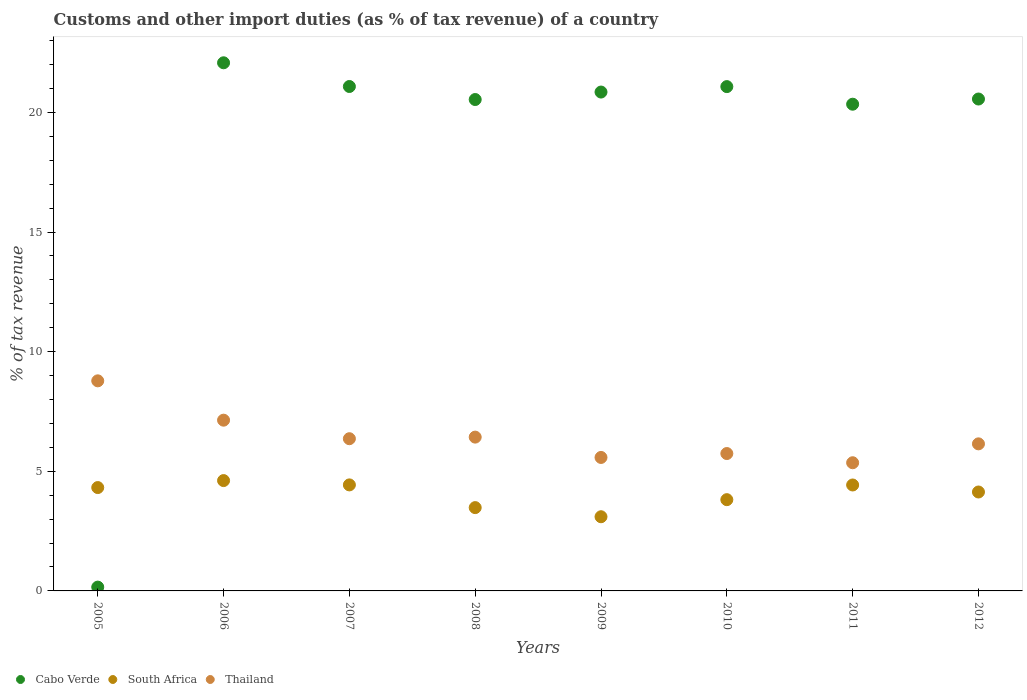How many different coloured dotlines are there?
Offer a terse response. 3. What is the percentage of tax revenue from customs in Cabo Verde in 2007?
Provide a succinct answer. 21.08. Across all years, what is the maximum percentage of tax revenue from customs in Cabo Verde?
Provide a succinct answer. 22.07. Across all years, what is the minimum percentage of tax revenue from customs in South Africa?
Keep it short and to the point. 3.1. In which year was the percentage of tax revenue from customs in Cabo Verde maximum?
Provide a short and direct response. 2006. In which year was the percentage of tax revenue from customs in South Africa minimum?
Provide a short and direct response. 2009. What is the total percentage of tax revenue from customs in Thailand in the graph?
Your answer should be very brief. 51.53. What is the difference between the percentage of tax revenue from customs in Thailand in 2008 and that in 2011?
Provide a short and direct response. 1.07. What is the difference between the percentage of tax revenue from customs in South Africa in 2006 and the percentage of tax revenue from customs in Thailand in 2012?
Make the answer very short. -1.54. What is the average percentage of tax revenue from customs in South Africa per year?
Your response must be concise. 4.04. In the year 2005, what is the difference between the percentage of tax revenue from customs in South Africa and percentage of tax revenue from customs in Cabo Verde?
Your answer should be compact. 4.16. In how many years, is the percentage of tax revenue from customs in Cabo Verde greater than 10 %?
Make the answer very short. 7. What is the ratio of the percentage of tax revenue from customs in South Africa in 2008 to that in 2010?
Your response must be concise. 0.91. Is the percentage of tax revenue from customs in South Africa in 2007 less than that in 2009?
Your answer should be very brief. No. What is the difference between the highest and the second highest percentage of tax revenue from customs in Thailand?
Your answer should be very brief. 1.64. What is the difference between the highest and the lowest percentage of tax revenue from customs in South Africa?
Ensure brevity in your answer.  1.51. Is it the case that in every year, the sum of the percentage of tax revenue from customs in South Africa and percentage of tax revenue from customs in Cabo Verde  is greater than the percentage of tax revenue from customs in Thailand?
Provide a succinct answer. No. Does the percentage of tax revenue from customs in South Africa monotonically increase over the years?
Your response must be concise. No. How many dotlines are there?
Your answer should be compact. 3. How many years are there in the graph?
Your answer should be very brief. 8. Are the values on the major ticks of Y-axis written in scientific E-notation?
Offer a terse response. No. Does the graph contain any zero values?
Ensure brevity in your answer.  No. How many legend labels are there?
Your response must be concise. 3. How are the legend labels stacked?
Your answer should be very brief. Horizontal. What is the title of the graph?
Offer a very short reply. Customs and other import duties (as % of tax revenue) of a country. What is the label or title of the X-axis?
Keep it short and to the point. Years. What is the label or title of the Y-axis?
Keep it short and to the point. % of tax revenue. What is the % of tax revenue of Cabo Verde in 2005?
Ensure brevity in your answer.  0.16. What is the % of tax revenue of South Africa in 2005?
Your response must be concise. 4.32. What is the % of tax revenue in Thailand in 2005?
Offer a terse response. 8.78. What is the % of tax revenue in Cabo Verde in 2006?
Make the answer very short. 22.07. What is the % of tax revenue of South Africa in 2006?
Provide a succinct answer. 4.61. What is the % of tax revenue in Thailand in 2006?
Provide a succinct answer. 7.14. What is the % of tax revenue of Cabo Verde in 2007?
Provide a short and direct response. 21.08. What is the % of tax revenue of South Africa in 2007?
Ensure brevity in your answer.  4.43. What is the % of tax revenue of Thailand in 2007?
Make the answer very short. 6.36. What is the % of tax revenue in Cabo Verde in 2008?
Offer a terse response. 20.54. What is the % of tax revenue of South Africa in 2008?
Offer a terse response. 3.48. What is the % of tax revenue of Thailand in 2008?
Ensure brevity in your answer.  6.43. What is the % of tax revenue in Cabo Verde in 2009?
Provide a succinct answer. 20.85. What is the % of tax revenue in South Africa in 2009?
Your answer should be compact. 3.1. What is the % of tax revenue of Thailand in 2009?
Offer a terse response. 5.58. What is the % of tax revenue in Cabo Verde in 2010?
Your answer should be compact. 21.08. What is the % of tax revenue of South Africa in 2010?
Your answer should be compact. 3.81. What is the % of tax revenue in Thailand in 2010?
Provide a short and direct response. 5.74. What is the % of tax revenue in Cabo Verde in 2011?
Your response must be concise. 20.34. What is the % of tax revenue in South Africa in 2011?
Your answer should be very brief. 4.43. What is the % of tax revenue in Thailand in 2011?
Your response must be concise. 5.36. What is the % of tax revenue of Cabo Verde in 2012?
Offer a very short reply. 20.56. What is the % of tax revenue in South Africa in 2012?
Your response must be concise. 4.13. What is the % of tax revenue in Thailand in 2012?
Make the answer very short. 6.15. Across all years, what is the maximum % of tax revenue in Cabo Verde?
Make the answer very short. 22.07. Across all years, what is the maximum % of tax revenue of South Africa?
Ensure brevity in your answer.  4.61. Across all years, what is the maximum % of tax revenue of Thailand?
Offer a very short reply. 8.78. Across all years, what is the minimum % of tax revenue in Cabo Verde?
Your answer should be compact. 0.16. Across all years, what is the minimum % of tax revenue in South Africa?
Offer a terse response. 3.1. Across all years, what is the minimum % of tax revenue of Thailand?
Keep it short and to the point. 5.36. What is the total % of tax revenue in Cabo Verde in the graph?
Ensure brevity in your answer.  146.69. What is the total % of tax revenue in South Africa in the graph?
Keep it short and to the point. 32.32. What is the total % of tax revenue in Thailand in the graph?
Your response must be concise. 51.53. What is the difference between the % of tax revenue of Cabo Verde in 2005 and that in 2006?
Provide a short and direct response. -21.91. What is the difference between the % of tax revenue in South Africa in 2005 and that in 2006?
Offer a terse response. -0.29. What is the difference between the % of tax revenue of Thailand in 2005 and that in 2006?
Keep it short and to the point. 1.64. What is the difference between the % of tax revenue in Cabo Verde in 2005 and that in 2007?
Your answer should be very brief. -20.92. What is the difference between the % of tax revenue in South Africa in 2005 and that in 2007?
Your response must be concise. -0.11. What is the difference between the % of tax revenue in Thailand in 2005 and that in 2007?
Your answer should be compact. 2.42. What is the difference between the % of tax revenue of Cabo Verde in 2005 and that in 2008?
Offer a very short reply. -20.38. What is the difference between the % of tax revenue of South Africa in 2005 and that in 2008?
Ensure brevity in your answer.  0.84. What is the difference between the % of tax revenue of Thailand in 2005 and that in 2008?
Provide a succinct answer. 2.35. What is the difference between the % of tax revenue of Cabo Verde in 2005 and that in 2009?
Make the answer very short. -20.69. What is the difference between the % of tax revenue in South Africa in 2005 and that in 2009?
Keep it short and to the point. 1.22. What is the difference between the % of tax revenue of Thailand in 2005 and that in 2009?
Your answer should be very brief. 3.2. What is the difference between the % of tax revenue in Cabo Verde in 2005 and that in 2010?
Make the answer very short. -20.92. What is the difference between the % of tax revenue in South Africa in 2005 and that in 2010?
Provide a short and direct response. 0.51. What is the difference between the % of tax revenue of Thailand in 2005 and that in 2010?
Ensure brevity in your answer.  3.04. What is the difference between the % of tax revenue in Cabo Verde in 2005 and that in 2011?
Keep it short and to the point. -20.18. What is the difference between the % of tax revenue of South Africa in 2005 and that in 2011?
Provide a short and direct response. -0.11. What is the difference between the % of tax revenue in Thailand in 2005 and that in 2011?
Provide a short and direct response. 3.42. What is the difference between the % of tax revenue of Cabo Verde in 2005 and that in 2012?
Make the answer very short. -20.4. What is the difference between the % of tax revenue in South Africa in 2005 and that in 2012?
Offer a terse response. 0.19. What is the difference between the % of tax revenue of Thailand in 2005 and that in 2012?
Provide a succinct answer. 2.63. What is the difference between the % of tax revenue of Cabo Verde in 2006 and that in 2007?
Your answer should be compact. 0.99. What is the difference between the % of tax revenue in South Africa in 2006 and that in 2007?
Your response must be concise. 0.18. What is the difference between the % of tax revenue of Thailand in 2006 and that in 2007?
Give a very brief answer. 0.77. What is the difference between the % of tax revenue of Cabo Verde in 2006 and that in 2008?
Your answer should be compact. 1.54. What is the difference between the % of tax revenue of South Africa in 2006 and that in 2008?
Offer a very short reply. 1.13. What is the difference between the % of tax revenue of Thailand in 2006 and that in 2008?
Provide a succinct answer. 0.71. What is the difference between the % of tax revenue in Cabo Verde in 2006 and that in 2009?
Your answer should be very brief. 1.22. What is the difference between the % of tax revenue of South Africa in 2006 and that in 2009?
Offer a terse response. 1.51. What is the difference between the % of tax revenue in Thailand in 2006 and that in 2009?
Ensure brevity in your answer.  1.56. What is the difference between the % of tax revenue of South Africa in 2006 and that in 2010?
Make the answer very short. 0.8. What is the difference between the % of tax revenue in Thailand in 2006 and that in 2010?
Give a very brief answer. 1.39. What is the difference between the % of tax revenue in Cabo Verde in 2006 and that in 2011?
Offer a terse response. 1.73. What is the difference between the % of tax revenue of South Africa in 2006 and that in 2011?
Your response must be concise. 0.18. What is the difference between the % of tax revenue in Thailand in 2006 and that in 2011?
Ensure brevity in your answer.  1.78. What is the difference between the % of tax revenue of Cabo Verde in 2006 and that in 2012?
Offer a terse response. 1.51. What is the difference between the % of tax revenue of South Africa in 2006 and that in 2012?
Provide a short and direct response. 0.48. What is the difference between the % of tax revenue of Thailand in 2006 and that in 2012?
Your answer should be very brief. 0.99. What is the difference between the % of tax revenue in Cabo Verde in 2007 and that in 2008?
Your response must be concise. 0.54. What is the difference between the % of tax revenue in South Africa in 2007 and that in 2008?
Make the answer very short. 0.95. What is the difference between the % of tax revenue in Thailand in 2007 and that in 2008?
Provide a short and direct response. -0.07. What is the difference between the % of tax revenue in Cabo Verde in 2007 and that in 2009?
Make the answer very short. 0.23. What is the difference between the % of tax revenue of South Africa in 2007 and that in 2009?
Your answer should be compact. 1.33. What is the difference between the % of tax revenue of Thailand in 2007 and that in 2009?
Provide a succinct answer. 0.78. What is the difference between the % of tax revenue of Cabo Verde in 2007 and that in 2010?
Offer a terse response. 0. What is the difference between the % of tax revenue of South Africa in 2007 and that in 2010?
Keep it short and to the point. 0.62. What is the difference between the % of tax revenue of Thailand in 2007 and that in 2010?
Keep it short and to the point. 0.62. What is the difference between the % of tax revenue in Cabo Verde in 2007 and that in 2011?
Offer a very short reply. 0.74. What is the difference between the % of tax revenue in South Africa in 2007 and that in 2011?
Your answer should be very brief. 0. What is the difference between the % of tax revenue in Cabo Verde in 2007 and that in 2012?
Keep it short and to the point. 0.52. What is the difference between the % of tax revenue of South Africa in 2007 and that in 2012?
Your answer should be very brief. 0.3. What is the difference between the % of tax revenue in Thailand in 2007 and that in 2012?
Offer a very short reply. 0.21. What is the difference between the % of tax revenue of Cabo Verde in 2008 and that in 2009?
Provide a short and direct response. -0.31. What is the difference between the % of tax revenue in South Africa in 2008 and that in 2009?
Ensure brevity in your answer.  0.38. What is the difference between the % of tax revenue of Thailand in 2008 and that in 2009?
Provide a succinct answer. 0.85. What is the difference between the % of tax revenue in Cabo Verde in 2008 and that in 2010?
Provide a succinct answer. -0.54. What is the difference between the % of tax revenue of South Africa in 2008 and that in 2010?
Your response must be concise. -0.33. What is the difference between the % of tax revenue in Thailand in 2008 and that in 2010?
Provide a succinct answer. 0.69. What is the difference between the % of tax revenue in Cabo Verde in 2008 and that in 2011?
Your response must be concise. 0.2. What is the difference between the % of tax revenue of South Africa in 2008 and that in 2011?
Make the answer very short. -0.95. What is the difference between the % of tax revenue in Thailand in 2008 and that in 2011?
Make the answer very short. 1.07. What is the difference between the % of tax revenue of Cabo Verde in 2008 and that in 2012?
Offer a very short reply. -0.02. What is the difference between the % of tax revenue of South Africa in 2008 and that in 2012?
Your response must be concise. -0.65. What is the difference between the % of tax revenue in Thailand in 2008 and that in 2012?
Keep it short and to the point. 0.28. What is the difference between the % of tax revenue in Cabo Verde in 2009 and that in 2010?
Offer a terse response. -0.23. What is the difference between the % of tax revenue in South Africa in 2009 and that in 2010?
Ensure brevity in your answer.  -0.71. What is the difference between the % of tax revenue in Thailand in 2009 and that in 2010?
Ensure brevity in your answer.  -0.16. What is the difference between the % of tax revenue of Cabo Verde in 2009 and that in 2011?
Keep it short and to the point. 0.51. What is the difference between the % of tax revenue of South Africa in 2009 and that in 2011?
Your response must be concise. -1.33. What is the difference between the % of tax revenue in Thailand in 2009 and that in 2011?
Your response must be concise. 0.22. What is the difference between the % of tax revenue in Cabo Verde in 2009 and that in 2012?
Your answer should be compact. 0.29. What is the difference between the % of tax revenue in South Africa in 2009 and that in 2012?
Provide a short and direct response. -1.03. What is the difference between the % of tax revenue of Thailand in 2009 and that in 2012?
Ensure brevity in your answer.  -0.57. What is the difference between the % of tax revenue of Cabo Verde in 2010 and that in 2011?
Make the answer very short. 0.74. What is the difference between the % of tax revenue of South Africa in 2010 and that in 2011?
Keep it short and to the point. -0.61. What is the difference between the % of tax revenue of Thailand in 2010 and that in 2011?
Your response must be concise. 0.38. What is the difference between the % of tax revenue in Cabo Verde in 2010 and that in 2012?
Offer a terse response. 0.52. What is the difference between the % of tax revenue of South Africa in 2010 and that in 2012?
Your answer should be compact. -0.32. What is the difference between the % of tax revenue of Thailand in 2010 and that in 2012?
Ensure brevity in your answer.  -0.4. What is the difference between the % of tax revenue in Cabo Verde in 2011 and that in 2012?
Your response must be concise. -0.22. What is the difference between the % of tax revenue of South Africa in 2011 and that in 2012?
Offer a terse response. 0.29. What is the difference between the % of tax revenue of Thailand in 2011 and that in 2012?
Provide a short and direct response. -0.79. What is the difference between the % of tax revenue of Cabo Verde in 2005 and the % of tax revenue of South Africa in 2006?
Make the answer very short. -4.45. What is the difference between the % of tax revenue in Cabo Verde in 2005 and the % of tax revenue in Thailand in 2006?
Your answer should be compact. -6.98. What is the difference between the % of tax revenue of South Africa in 2005 and the % of tax revenue of Thailand in 2006?
Keep it short and to the point. -2.82. What is the difference between the % of tax revenue in Cabo Verde in 2005 and the % of tax revenue in South Africa in 2007?
Provide a succinct answer. -4.27. What is the difference between the % of tax revenue in Cabo Verde in 2005 and the % of tax revenue in Thailand in 2007?
Your response must be concise. -6.2. What is the difference between the % of tax revenue of South Africa in 2005 and the % of tax revenue of Thailand in 2007?
Provide a succinct answer. -2.04. What is the difference between the % of tax revenue in Cabo Verde in 2005 and the % of tax revenue in South Africa in 2008?
Offer a terse response. -3.32. What is the difference between the % of tax revenue in Cabo Verde in 2005 and the % of tax revenue in Thailand in 2008?
Provide a succinct answer. -6.27. What is the difference between the % of tax revenue in South Africa in 2005 and the % of tax revenue in Thailand in 2008?
Provide a short and direct response. -2.11. What is the difference between the % of tax revenue of Cabo Verde in 2005 and the % of tax revenue of South Africa in 2009?
Make the answer very short. -2.94. What is the difference between the % of tax revenue of Cabo Verde in 2005 and the % of tax revenue of Thailand in 2009?
Ensure brevity in your answer.  -5.42. What is the difference between the % of tax revenue in South Africa in 2005 and the % of tax revenue in Thailand in 2009?
Make the answer very short. -1.26. What is the difference between the % of tax revenue in Cabo Verde in 2005 and the % of tax revenue in South Africa in 2010?
Make the answer very short. -3.65. What is the difference between the % of tax revenue in Cabo Verde in 2005 and the % of tax revenue in Thailand in 2010?
Make the answer very short. -5.58. What is the difference between the % of tax revenue in South Africa in 2005 and the % of tax revenue in Thailand in 2010?
Your answer should be compact. -1.42. What is the difference between the % of tax revenue in Cabo Verde in 2005 and the % of tax revenue in South Africa in 2011?
Provide a short and direct response. -4.27. What is the difference between the % of tax revenue of Cabo Verde in 2005 and the % of tax revenue of Thailand in 2011?
Provide a short and direct response. -5.2. What is the difference between the % of tax revenue in South Africa in 2005 and the % of tax revenue in Thailand in 2011?
Your response must be concise. -1.04. What is the difference between the % of tax revenue of Cabo Verde in 2005 and the % of tax revenue of South Africa in 2012?
Provide a short and direct response. -3.98. What is the difference between the % of tax revenue of Cabo Verde in 2005 and the % of tax revenue of Thailand in 2012?
Provide a succinct answer. -5.99. What is the difference between the % of tax revenue in South Africa in 2005 and the % of tax revenue in Thailand in 2012?
Provide a short and direct response. -1.83. What is the difference between the % of tax revenue in Cabo Verde in 2006 and the % of tax revenue in South Africa in 2007?
Offer a very short reply. 17.64. What is the difference between the % of tax revenue of Cabo Verde in 2006 and the % of tax revenue of Thailand in 2007?
Offer a very short reply. 15.71. What is the difference between the % of tax revenue in South Africa in 2006 and the % of tax revenue in Thailand in 2007?
Make the answer very short. -1.75. What is the difference between the % of tax revenue of Cabo Verde in 2006 and the % of tax revenue of South Africa in 2008?
Your answer should be very brief. 18.59. What is the difference between the % of tax revenue of Cabo Verde in 2006 and the % of tax revenue of Thailand in 2008?
Offer a very short reply. 15.65. What is the difference between the % of tax revenue in South Africa in 2006 and the % of tax revenue in Thailand in 2008?
Your response must be concise. -1.82. What is the difference between the % of tax revenue of Cabo Verde in 2006 and the % of tax revenue of South Africa in 2009?
Provide a succinct answer. 18.97. What is the difference between the % of tax revenue in Cabo Verde in 2006 and the % of tax revenue in Thailand in 2009?
Your answer should be compact. 16.5. What is the difference between the % of tax revenue of South Africa in 2006 and the % of tax revenue of Thailand in 2009?
Provide a succinct answer. -0.97. What is the difference between the % of tax revenue of Cabo Verde in 2006 and the % of tax revenue of South Africa in 2010?
Make the answer very short. 18.26. What is the difference between the % of tax revenue of Cabo Verde in 2006 and the % of tax revenue of Thailand in 2010?
Ensure brevity in your answer.  16.33. What is the difference between the % of tax revenue of South Africa in 2006 and the % of tax revenue of Thailand in 2010?
Provide a short and direct response. -1.13. What is the difference between the % of tax revenue of Cabo Verde in 2006 and the % of tax revenue of South Africa in 2011?
Your answer should be compact. 17.65. What is the difference between the % of tax revenue of Cabo Verde in 2006 and the % of tax revenue of Thailand in 2011?
Give a very brief answer. 16.72. What is the difference between the % of tax revenue of South Africa in 2006 and the % of tax revenue of Thailand in 2011?
Ensure brevity in your answer.  -0.75. What is the difference between the % of tax revenue in Cabo Verde in 2006 and the % of tax revenue in South Africa in 2012?
Provide a short and direct response. 17.94. What is the difference between the % of tax revenue of Cabo Verde in 2006 and the % of tax revenue of Thailand in 2012?
Make the answer very short. 15.93. What is the difference between the % of tax revenue of South Africa in 2006 and the % of tax revenue of Thailand in 2012?
Ensure brevity in your answer.  -1.54. What is the difference between the % of tax revenue of Cabo Verde in 2007 and the % of tax revenue of South Africa in 2008?
Your response must be concise. 17.6. What is the difference between the % of tax revenue in Cabo Verde in 2007 and the % of tax revenue in Thailand in 2008?
Make the answer very short. 14.65. What is the difference between the % of tax revenue of South Africa in 2007 and the % of tax revenue of Thailand in 2008?
Give a very brief answer. -2. What is the difference between the % of tax revenue in Cabo Verde in 2007 and the % of tax revenue in South Africa in 2009?
Make the answer very short. 17.98. What is the difference between the % of tax revenue in Cabo Verde in 2007 and the % of tax revenue in Thailand in 2009?
Give a very brief answer. 15.5. What is the difference between the % of tax revenue of South Africa in 2007 and the % of tax revenue of Thailand in 2009?
Offer a terse response. -1.15. What is the difference between the % of tax revenue in Cabo Verde in 2007 and the % of tax revenue in South Africa in 2010?
Keep it short and to the point. 17.27. What is the difference between the % of tax revenue in Cabo Verde in 2007 and the % of tax revenue in Thailand in 2010?
Your answer should be compact. 15.34. What is the difference between the % of tax revenue of South Africa in 2007 and the % of tax revenue of Thailand in 2010?
Offer a very short reply. -1.31. What is the difference between the % of tax revenue in Cabo Verde in 2007 and the % of tax revenue in South Africa in 2011?
Offer a terse response. 16.66. What is the difference between the % of tax revenue of Cabo Verde in 2007 and the % of tax revenue of Thailand in 2011?
Give a very brief answer. 15.73. What is the difference between the % of tax revenue of South Africa in 2007 and the % of tax revenue of Thailand in 2011?
Provide a succinct answer. -0.93. What is the difference between the % of tax revenue of Cabo Verde in 2007 and the % of tax revenue of South Africa in 2012?
Your answer should be very brief. 16.95. What is the difference between the % of tax revenue in Cabo Verde in 2007 and the % of tax revenue in Thailand in 2012?
Keep it short and to the point. 14.94. What is the difference between the % of tax revenue in South Africa in 2007 and the % of tax revenue in Thailand in 2012?
Your response must be concise. -1.72. What is the difference between the % of tax revenue of Cabo Verde in 2008 and the % of tax revenue of South Africa in 2009?
Provide a succinct answer. 17.44. What is the difference between the % of tax revenue in Cabo Verde in 2008 and the % of tax revenue in Thailand in 2009?
Your response must be concise. 14.96. What is the difference between the % of tax revenue of South Africa in 2008 and the % of tax revenue of Thailand in 2009?
Your answer should be compact. -2.1. What is the difference between the % of tax revenue in Cabo Verde in 2008 and the % of tax revenue in South Africa in 2010?
Ensure brevity in your answer.  16.72. What is the difference between the % of tax revenue in Cabo Verde in 2008 and the % of tax revenue in Thailand in 2010?
Ensure brevity in your answer.  14.8. What is the difference between the % of tax revenue of South Africa in 2008 and the % of tax revenue of Thailand in 2010?
Your answer should be compact. -2.26. What is the difference between the % of tax revenue in Cabo Verde in 2008 and the % of tax revenue in South Africa in 2011?
Your answer should be compact. 16.11. What is the difference between the % of tax revenue in Cabo Verde in 2008 and the % of tax revenue in Thailand in 2011?
Offer a very short reply. 15.18. What is the difference between the % of tax revenue in South Africa in 2008 and the % of tax revenue in Thailand in 2011?
Offer a very short reply. -1.88. What is the difference between the % of tax revenue in Cabo Verde in 2008 and the % of tax revenue in South Africa in 2012?
Your answer should be compact. 16.4. What is the difference between the % of tax revenue of Cabo Verde in 2008 and the % of tax revenue of Thailand in 2012?
Keep it short and to the point. 14.39. What is the difference between the % of tax revenue of South Africa in 2008 and the % of tax revenue of Thailand in 2012?
Provide a short and direct response. -2.66. What is the difference between the % of tax revenue of Cabo Verde in 2009 and the % of tax revenue of South Africa in 2010?
Your answer should be very brief. 17.04. What is the difference between the % of tax revenue in Cabo Verde in 2009 and the % of tax revenue in Thailand in 2010?
Offer a terse response. 15.11. What is the difference between the % of tax revenue of South Africa in 2009 and the % of tax revenue of Thailand in 2010?
Give a very brief answer. -2.64. What is the difference between the % of tax revenue in Cabo Verde in 2009 and the % of tax revenue in South Africa in 2011?
Ensure brevity in your answer.  16.42. What is the difference between the % of tax revenue in Cabo Verde in 2009 and the % of tax revenue in Thailand in 2011?
Provide a succinct answer. 15.49. What is the difference between the % of tax revenue in South Africa in 2009 and the % of tax revenue in Thailand in 2011?
Your answer should be very brief. -2.26. What is the difference between the % of tax revenue in Cabo Verde in 2009 and the % of tax revenue in South Africa in 2012?
Provide a succinct answer. 16.72. What is the difference between the % of tax revenue of Cabo Verde in 2009 and the % of tax revenue of Thailand in 2012?
Your answer should be very brief. 14.7. What is the difference between the % of tax revenue in South Africa in 2009 and the % of tax revenue in Thailand in 2012?
Make the answer very short. -3.05. What is the difference between the % of tax revenue of Cabo Verde in 2010 and the % of tax revenue of South Africa in 2011?
Your answer should be very brief. 16.65. What is the difference between the % of tax revenue in Cabo Verde in 2010 and the % of tax revenue in Thailand in 2011?
Ensure brevity in your answer.  15.72. What is the difference between the % of tax revenue in South Africa in 2010 and the % of tax revenue in Thailand in 2011?
Provide a succinct answer. -1.54. What is the difference between the % of tax revenue in Cabo Verde in 2010 and the % of tax revenue in South Africa in 2012?
Offer a terse response. 16.94. What is the difference between the % of tax revenue in Cabo Verde in 2010 and the % of tax revenue in Thailand in 2012?
Your answer should be very brief. 14.93. What is the difference between the % of tax revenue of South Africa in 2010 and the % of tax revenue of Thailand in 2012?
Your answer should be compact. -2.33. What is the difference between the % of tax revenue of Cabo Verde in 2011 and the % of tax revenue of South Africa in 2012?
Your response must be concise. 16.21. What is the difference between the % of tax revenue of Cabo Verde in 2011 and the % of tax revenue of Thailand in 2012?
Ensure brevity in your answer.  14.2. What is the difference between the % of tax revenue in South Africa in 2011 and the % of tax revenue in Thailand in 2012?
Provide a short and direct response. -1.72. What is the average % of tax revenue of Cabo Verde per year?
Ensure brevity in your answer.  18.34. What is the average % of tax revenue of South Africa per year?
Give a very brief answer. 4.04. What is the average % of tax revenue in Thailand per year?
Offer a very short reply. 6.44. In the year 2005, what is the difference between the % of tax revenue of Cabo Verde and % of tax revenue of South Africa?
Keep it short and to the point. -4.16. In the year 2005, what is the difference between the % of tax revenue of Cabo Verde and % of tax revenue of Thailand?
Your answer should be very brief. -8.62. In the year 2005, what is the difference between the % of tax revenue of South Africa and % of tax revenue of Thailand?
Your response must be concise. -4.46. In the year 2006, what is the difference between the % of tax revenue of Cabo Verde and % of tax revenue of South Africa?
Keep it short and to the point. 17.46. In the year 2006, what is the difference between the % of tax revenue of Cabo Verde and % of tax revenue of Thailand?
Offer a terse response. 14.94. In the year 2006, what is the difference between the % of tax revenue of South Africa and % of tax revenue of Thailand?
Keep it short and to the point. -2.52. In the year 2007, what is the difference between the % of tax revenue in Cabo Verde and % of tax revenue in South Africa?
Make the answer very short. 16.65. In the year 2007, what is the difference between the % of tax revenue in Cabo Verde and % of tax revenue in Thailand?
Give a very brief answer. 14.72. In the year 2007, what is the difference between the % of tax revenue in South Africa and % of tax revenue in Thailand?
Give a very brief answer. -1.93. In the year 2008, what is the difference between the % of tax revenue in Cabo Verde and % of tax revenue in South Africa?
Your answer should be very brief. 17.06. In the year 2008, what is the difference between the % of tax revenue of Cabo Verde and % of tax revenue of Thailand?
Ensure brevity in your answer.  14.11. In the year 2008, what is the difference between the % of tax revenue of South Africa and % of tax revenue of Thailand?
Your response must be concise. -2.95. In the year 2009, what is the difference between the % of tax revenue of Cabo Verde and % of tax revenue of South Africa?
Provide a succinct answer. 17.75. In the year 2009, what is the difference between the % of tax revenue in Cabo Verde and % of tax revenue in Thailand?
Provide a succinct answer. 15.27. In the year 2009, what is the difference between the % of tax revenue of South Africa and % of tax revenue of Thailand?
Offer a very short reply. -2.48. In the year 2010, what is the difference between the % of tax revenue of Cabo Verde and % of tax revenue of South Africa?
Provide a short and direct response. 17.26. In the year 2010, what is the difference between the % of tax revenue of Cabo Verde and % of tax revenue of Thailand?
Provide a short and direct response. 15.34. In the year 2010, what is the difference between the % of tax revenue in South Africa and % of tax revenue in Thailand?
Ensure brevity in your answer.  -1.93. In the year 2011, what is the difference between the % of tax revenue of Cabo Verde and % of tax revenue of South Africa?
Your response must be concise. 15.92. In the year 2011, what is the difference between the % of tax revenue in Cabo Verde and % of tax revenue in Thailand?
Offer a terse response. 14.99. In the year 2011, what is the difference between the % of tax revenue of South Africa and % of tax revenue of Thailand?
Provide a short and direct response. -0.93. In the year 2012, what is the difference between the % of tax revenue of Cabo Verde and % of tax revenue of South Africa?
Provide a succinct answer. 16.43. In the year 2012, what is the difference between the % of tax revenue in Cabo Verde and % of tax revenue in Thailand?
Your answer should be compact. 14.41. In the year 2012, what is the difference between the % of tax revenue in South Africa and % of tax revenue in Thailand?
Ensure brevity in your answer.  -2.01. What is the ratio of the % of tax revenue of Cabo Verde in 2005 to that in 2006?
Offer a very short reply. 0.01. What is the ratio of the % of tax revenue of South Africa in 2005 to that in 2006?
Offer a very short reply. 0.94. What is the ratio of the % of tax revenue of Thailand in 2005 to that in 2006?
Give a very brief answer. 1.23. What is the ratio of the % of tax revenue of Cabo Verde in 2005 to that in 2007?
Offer a very short reply. 0.01. What is the ratio of the % of tax revenue of South Africa in 2005 to that in 2007?
Provide a short and direct response. 0.97. What is the ratio of the % of tax revenue of Thailand in 2005 to that in 2007?
Offer a very short reply. 1.38. What is the ratio of the % of tax revenue in Cabo Verde in 2005 to that in 2008?
Offer a terse response. 0.01. What is the ratio of the % of tax revenue of South Africa in 2005 to that in 2008?
Provide a succinct answer. 1.24. What is the ratio of the % of tax revenue in Thailand in 2005 to that in 2008?
Offer a very short reply. 1.37. What is the ratio of the % of tax revenue in Cabo Verde in 2005 to that in 2009?
Provide a succinct answer. 0.01. What is the ratio of the % of tax revenue in South Africa in 2005 to that in 2009?
Offer a terse response. 1.39. What is the ratio of the % of tax revenue in Thailand in 2005 to that in 2009?
Your answer should be compact. 1.57. What is the ratio of the % of tax revenue in Cabo Verde in 2005 to that in 2010?
Offer a terse response. 0.01. What is the ratio of the % of tax revenue in South Africa in 2005 to that in 2010?
Ensure brevity in your answer.  1.13. What is the ratio of the % of tax revenue in Thailand in 2005 to that in 2010?
Give a very brief answer. 1.53. What is the ratio of the % of tax revenue of Cabo Verde in 2005 to that in 2011?
Your response must be concise. 0.01. What is the ratio of the % of tax revenue in South Africa in 2005 to that in 2011?
Offer a very short reply. 0.98. What is the ratio of the % of tax revenue of Thailand in 2005 to that in 2011?
Your answer should be very brief. 1.64. What is the ratio of the % of tax revenue of Cabo Verde in 2005 to that in 2012?
Keep it short and to the point. 0.01. What is the ratio of the % of tax revenue of South Africa in 2005 to that in 2012?
Make the answer very short. 1.04. What is the ratio of the % of tax revenue of Thailand in 2005 to that in 2012?
Provide a succinct answer. 1.43. What is the ratio of the % of tax revenue in Cabo Verde in 2006 to that in 2007?
Your answer should be very brief. 1.05. What is the ratio of the % of tax revenue in South Africa in 2006 to that in 2007?
Offer a terse response. 1.04. What is the ratio of the % of tax revenue of Thailand in 2006 to that in 2007?
Ensure brevity in your answer.  1.12. What is the ratio of the % of tax revenue in Cabo Verde in 2006 to that in 2008?
Offer a terse response. 1.07. What is the ratio of the % of tax revenue in South Africa in 2006 to that in 2008?
Provide a short and direct response. 1.32. What is the ratio of the % of tax revenue of Thailand in 2006 to that in 2008?
Ensure brevity in your answer.  1.11. What is the ratio of the % of tax revenue in Cabo Verde in 2006 to that in 2009?
Provide a short and direct response. 1.06. What is the ratio of the % of tax revenue of South Africa in 2006 to that in 2009?
Your response must be concise. 1.49. What is the ratio of the % of tax revenue of Thailand in 2006 to that in 2009?
Provide a succinct answer. 1.28. What is the ratio of the % of tax revenue in Cabo Verde in 2006 to that in 2010?
Offer a terse response. 1.05. What is the ratio of the % of tax revenue in South Africa in 2006 to that in 2010?
Your answer should be compact. 1.21. What is the ratio of the % of tax revenue in Thailand in 2006 to that in 2010?
Offer a terse response. 1.24. What is the ratio of the % of tax revenue of Cabo Verde in 2006 to that in 2011?
Provide a short and direct response. 1.09. What is the ratio of the % of tax revenue of South Africa in 2006 to that in 2011?
Provide a succinct answer. 1.04. What is the ratio of the % of tax revenue of Thailand in 2006 to that in 2011?
Your answer should be very brief. 1.33. What is the ratio of the % of tax revenue of Cabo Verde in 2006 to that in 2012?
Your response must be concise. 1.07. What is the ratio of the % of tax revenue in South Africa in 2006 to that in 2012?
Make the answer very short. 1.12. What is the ratio of the % of tax revenue in Thailand in 2006 to that in 2012?
Make the answer very short. 1.16. What is the ratio of the % of tax revenue in Cabo Verde in 2007 to that in 2008?
Your response must be concise. 1.03. What is the ratio of the % of tax revenue of South Africa in 2007 to that in 2008?
Provide a succinct answer. 1.27. What is the ratio of the % of tax revenue of Thailand in 2007 to that in 2008?
Your answer should be very brief. 0.99. What is the ratio of the % of tax revenue in Cabo Verde in 2007 to that in 2009?
Your answer should be very brief. 1.01. What is the ratio of the % of tax revenue in South Africa in 2007 to that in 2009?
Your response must be concise. 1.43. What is the ratio of the % of tax revenue of Thailand in 2007 to that in 2009?
Your response must be concise. 1.14. What is the ratio of the % of tax revenue in South Africa in 2007 to that in 2010?
Provide a succinct answer. 1.16. What is the ratio of the % of tax revenue in Thailand in 2007 to that in 2010?
Your answer should be compact. 1.11. What is the ratio of the % of tax revenue of Cabo Verde in 2007 to that in 2011?
Keep it short and to the point. 1.04. What is the ratio of the % of tax revenue in Thailand in 2007 to that in 2011?
Offer a very short reply. 1.19. What is the ratio of the % of tax revenue in Cabo Verde in 2007 to that in 2012?
Offer a terse response. 1.03. What is the ratio of the % of tax revenue in South Africa in 2007 to that in 2012?
Your response must be concise. 1.07. What is the ratio of the % of tax revenue in Thailand in 2007 to that in 2012?
Give a very brief answer. 1.03. What is the ratio of the % of tax revenue in Cabo Verde in 2008 to that in 2009?
Your answer should be very brief. 0.98. What is the ratio of the % of tax revenue of South Africa in 2008 to that in 2009?
Your response must be concise. 1.12. What is the ratio of the % of tax revenue in Thailand in 2008 to that in 2009?
Keep it short and to the point. 1.15. What is the ratio of the % of tax revenue of Cabo Verde in 2008 to that in 2010?
Provide a short and direct response. 0.97. What is the ratio of the % of tax revenue of South Africa in 2008 to that in 2010?
Your answer should be compact. 0.91. What is the ratio of the % of tax revenue of Thailand in 2008 to that in 2010?
Offer a terse response. 1.12. What is the ratio of the % of tax revenue in Cabo Verde in 2008 to that in 2011?
Keep it short and to the point. 1.01. What is the ratio of the % of tax revenue in South Africa in 2008 to that in 2011?
Keep it short and to the point. 0.79. What is the ratio of the % of tax revenue of Thailand in 2008 to that in 2011?
Offer a very short reply. 1.2. What is the ratio of the % of tax revenue in Cabo Verde in 2008 to that in 2012?
Ensure brevity in your answer.  1. What is the ratio of the % of tax revenue of South Africa in 2008 to that in 2012?
Keep it short and to the point. 0.84. What is the ratio of the % of tax revenue of Thailand in 2008 to that in 2012?
Give a very brief answer. 1.05. What is the ratio of the % of tax revenue in Cabo Verde in 2009 to that in 2010?
Provide a short and direct response. 0.99. What is the ratio of the % of tax revenue in South Africa in 2009 to that in 2010?
Provide a short and direct response. 0.81. What is the ratio of the % of tax revenue in Thailand in 2009 to that in 2010?
Offer a terse response. 0.97. What is the ratio of the % of tax revenue of Cabo Verde in 2009 to that in 2011?
Your answer should be compact. 1.02. What is the ratio of the % of tax revenue in South Africa in 2009 to that in 2011?
Provide a succinct answer. 0.7. What is the ratio of the % of tax revenue of Thailand in 2009 to that in 2011?
Ensure brevity in your answer.  1.04. What is the ratio of the % of tax revenue in Cabo Verde in 2009 to that in 2012?
Ensure brevity in your answer.  1.01. What is the ratio of the % of tax revenue of South Africa in 2009 to that in 2012?
Provide a short and direct response. 0.75. What is the ratio of the % of tax revenue of Thailand in 2009 to that in 2012?
Ensure brevity in your answer.  0.91. What is the ratio of the % of tax revenue of Cabo Verde in 2010 to that in 2011?
Make the answer very short. 1.04. What is the ratio of the % of tax revenue in South Africa in 2010 to that in 2011?
Your answer should be compact. 0.86. What is the ratio of the % of tax revenue in Thailand in 2010 to that in 2011?
Provide a succinct answer. 1.07. What is the ratio of the % of tax revenue in Cabo Verde in 2010 to that in 2012?
Your response must be concise. 1.03. What is the ratio of the % of tax revenue in South Africa in 2010 to that in 2012?
Ensure brevity in your answer.  0.92. What is the ratio of the % of tax revenue of Thailand in 2010 to that in 2012?
Provide a succinct answer. 0.93. What is the ratio of the % of tax revenue in Cabo Verde in 2011 to that in 2012?
Your response must be concise. 0.99. What is the ratio of the % of tax revenue of South Africa in 2011 to that in 2012?
Ensure brevity in your answer.  1.07. What is the ratio of the % of tax revenue in Thailand in 2011 to that in 2012?
Make the answer very short. 0.87. What is the difference between the highest and the second highest % of tax revenue in Cabo Verde?
Ensure brevity in your answer.  0.99. What is the difference between the highest and the second highest % of tax revenue of South Africa?
Offer a very short reply. 0.18. What is the difference between the highest and the second highest % of tax revenue in Thailand?
Provide a succinct answer. 1.64. What is the difference between the highest and the lowest % of tax revenue of Cabo Verde?
Offer a very short reply. 21.91. What is the difference between the highest and the lowest % of tax revenue of South Africa?
Your answer should be compact. 1.51. What is the difference between the highest and the lowest % of tax revenue of Thailand?
Make the answer very short. 3.42. 